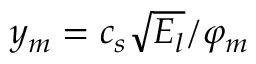<formula> <loc_0><loc_0><loc_500><loc_500>y _ { m } = c _ { s } \sqrt { E _ { l } } / \varphi _ { m }</formula> 